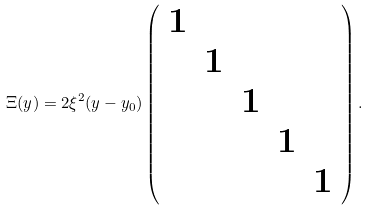<formula> <loc_0><loc_0><loc_500><loc_500>\Xi ( y ) = 2 \xi ^ { 2 } ( y - y _ { 0 } ) \left ( \begin{array} { c c c c c } 1 & & & & \\ & 1 & & & \\ & & 1 & & \\ & & & 1 & \\ & & & & 1 \end{array} \right ) .</formula> 